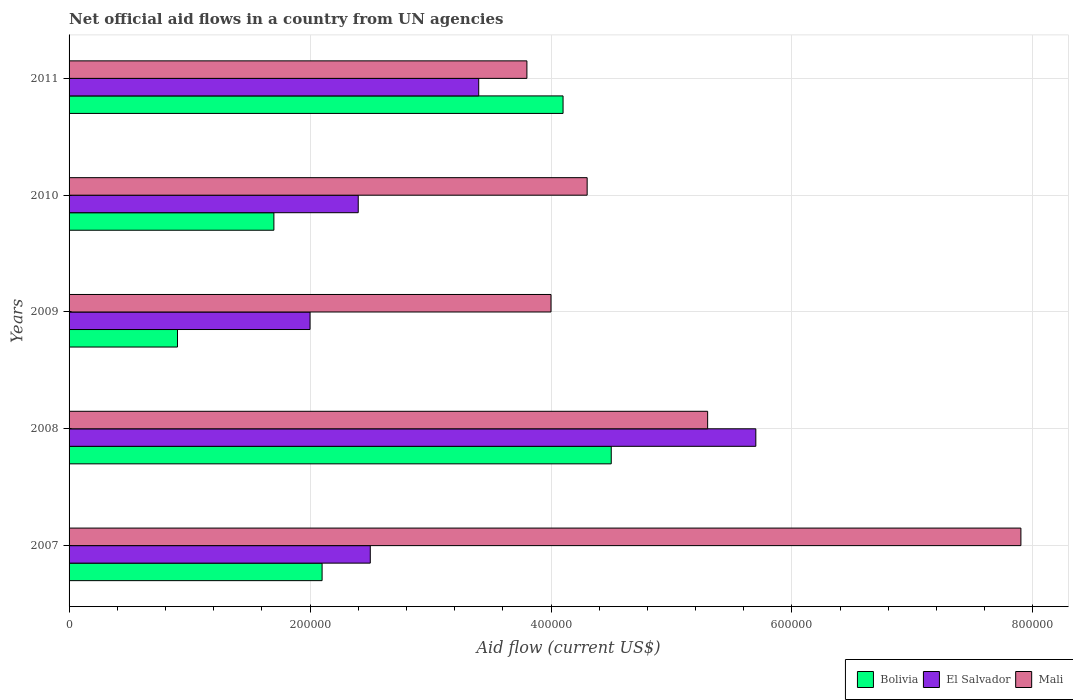Are the number of bars per tick equal to the number of legend labels?
Keep it short and to the point. Yes. How many bars are there on the 3rd tick from the top?
Your answer should be very brief. 3. In how many cases, is the number of bars for a given year not equal to the number of legend labels?
Provide a succinct answer. 0. What is the net official aid flow in Mali in 2008?
Give a very brief answer. 5.30e+05. Across all years, what is the maximum net official aid flow in Bolivia?
Your answer should be compact. 4.50e+05. Across all years, what is the minimum net official aid flow in El Salvador?
Ensure brevity in your answer.  2.00e+05. What is the total net official aid flow in Mali in the graph?
Offer a very short reply. 2.53e+06. What is the difference between the net official aid flow in Bolivia in 2007 and that in 2010?
Your answer should be very brief. 4.00e+04. What is the difference between the net official aid flow in El Salvador in 2011 and the net official aid flow in Mali in 2007?
Your response must be concise. -4.50e+05. What is the average net official aid flow in El Salvador per year?
Give a very brief answer. 3.20e+05. In the year 2009, what is the difference between the net official aid flow in Bolivia and net official aid flow in Mali?
Your response must be concise. -3.10e+05. What is the ratio of the net official aid flow in El Salvador in 2007 to that in 2008?
Your answer should be very brief. 0.44. Is the difference between the net official aid flow in Bolivia in 2007 and 2010 greater than the difference between the net official aid flow in Mali in 2007 and 2010?
Offer a very short reply. No. What is the difference between the highest and the second highest net official aid flow in Mali?
Ensure brevity in your answer.  2.60e+05. What is the difference between the highest and the lowest net official aid flow in El Salvador?
Make the answer very short. 3.70e+05. In how many years, is the net official aid flow in El Salvador greater than the average net official aid flow in El Salvador taken over all years?
Give a very brief answer. 2. What does the 2nd bar from the top in 2007 represents?
Ensure brevity in your answer.  El Salvador. What does the 2nd bar from the bottom in 2009 represents?
Provide a succinct answer. El Salvador. Is it the case that in every year, the sum of the net official aid flow in El Salvador and net official aid flow in Mali is greater than the net official aid flow in Bolivia?
Give a very brief answer. Yes. How many bars are there?
Provide a succinct answer. 15. How many years are there in the graph?
Your response must be concise. 5. Does the graph contain any zero values?
Keep it short and to the point. No. Where does the legend appear in the graph?
Provide a succinct answer. Bottom right. How are the legend labels stacked?
Give a very brief answer. Horizontal. What is the title of the graph?
Provide a succinct answer. Net official aid flows in a country from UN agencies. Does "India" appear as one of the legend labels in the graph?
Your answer should be very brief. No. What is the label or title of the Y-axis?
Offer a terse response. Years. What is the Aid flow (current US$) of Bolivia in 2007?
Provide a short and direct response. 2.10e+05. What is the Aid flow (current US$) in Mali in 2007?
Keep it short and to the point. 7.90e+05. What is the Aid flow (current US$) of El Salvador in 2008?
Give a very brief answer. 5.70e+05. What is the Aid flow (current US$) of Mali in 2008?
Give a very brief answer. 5.30e+05. What is the Aid flow (current US$) of El Salvador in 2009?
Make the answer very short. 2.00e+05. What is the Aid flow (current US$) in Bolivia in 2011?
Your answer should be very brief. 4.10e+05. Across all years, what is the maximum Aid flow (current US$) of Bolivia?
Provide a succinct answer. 4.50e+05. Across all years, what is the maximum Aid flow (current US$) of El Salvador?
Make the answer very short. 5.70e+05. Across all years, what is the maximum Aid flow (current US$) of Mali?
Make the answer very short. 7.90e+05. Across all years, what is the minimum Aid flow (current US$) in Bolivia?
Offer a terse response. 9.00e+04. Across all years, what is the minimum Aid flow (current US$) in El Salvador?
Your answer should be compact. 2.00e+05. What is the total Aid flow (current US$) of Bolivia in the graph?
Offer a terse response. 1.33e+06. What is the total Aid flow (current US$) of El Salvador in the graph?
Your answer should be very brief. 1.60e+06. What is the total Aid flow (current US$) in Mali in the graph?
Keep it short and to the point. 2.53e+06. What is the difference between the Aid flow (current US$) in Bolivia in 2007 and that in 2008?
Ensure brevity in your answer.  -2.40e+05. What is the difference between the Aid flow (current US$) in El Salvador in 2007 and that in 2008?
Give a very brief answer. -3.20e+05. What is the difference between the Aid flow (current US$) in Mali in 2007 and that in 2008?
Provide a succinct answer. 2.60e+05. What is the difference between the Aid flow (current US$) in El Salvador in 2007 and that in 2009?
Offer a terse response. 5.00e+04. What is the difference between the Aid flow (current US$) in Mali in 2007 and that in 2009?
Provide a short and direct response. 3.90e+05. What is the difference between the Aid flow (current US$) of Bolivia in 2007 and that in 2010?
Provide a succinct answer. 4.00e+04. What is the difference between the Aid flow (current US$) of El Salvador in 2007 and that in 2010?
Give a very brief answer. 10000. What is the difference between the Aid flow (current US$) in Bolivia in 2007 and that in 2011?
Make the answer very short. -2.00e+05. What is the difference between the Aid flow (current US$) of El Salvador in 2007 and that in 2011?
Make the answer very short. -9.00e+04. What is the difference between the Aid flow (current US$) in Mali in 2007 and that in 2011?
Offer a terse response. 4.10e+05. What is the difference between the Aid flow (current US$) of Bolivia in 2008 and that in 2009?
Make the answer very short. 3.60e+05. What is the difference between the Aid flow (current US$) in Mali in 2008 and that in 2009?
Provide a succinct answer. 1.30e+05. What is the difference between the Aid flow (current US$) of El Salvador in 2008 and that in 2010?
Provide a short and direct response. 3.30e+05. What is the difference between the Aid flow (current US$) of Mali in 2008 and that in 2010?
Your answer should be very brief. 1.00e+05. What is the difference between the Aid flow (current US$) in El Salvador in 2008 and that in 2011?
Offer a terse response. 2.30e+05. What is the difference between the Aid flow (current US$) in Mali in 2008 and that in 2011?
Make the answer very short. 1.50e+05. What is the difference between the Aid flow (current US$) of Bolivia in 2009 and that in 2010?
Provide a succinct answer. -8.00e+04. What is the difference between the Aid flow (current US$) of El Salvador in 2009 and that in 2010?
Your answer should be compact. -4.00e+04. What is the difference between the Aid flow (current US$) of Bolivia in 2009 and that in 2011?
Provide a succinct answer. -3.20e+05. What is the difference between the Aid flow (current US$) in El Salvador in 2009 and that in 2011?
Offer a terse response. -1.40e+05. What is the difference between the Aid flow (current US$) in Mali in 2009 and that in 2011?
Ensure brevity in your answer.  2.00e+04. What is the difference between the Aid flow (current US$) of Mali in 2010 and that in 2011?
Provide a short and direct response. 5.00e+04. What is the difference between the Aid flow (current US$) in Bolivia in 2007 and the Aid flow (current US$) in El Salvador in 2008?
Offer a terse response. -3.60e+05. What is the difference between the Aid flow (current US$) of Bolivia in 2007 and the Aid flow (current US$) of Mali in 2008?
Offer a very short reply. -3.20e+05. What is the difference between the Aid flow (current US$) of El Salvador in 2007 and the Aid flow (current US$) of Mali in 2008?
Provide a succinct answer. -2.80e+05. What is the difference between the Aid flow (current US$) in Bolivia in 2007 and the Aid flow (current US$) in El Salvador in 2009?
Your response must be concise. 10000. What is the difference between the Aid flow (current US$) in El Salvador in 2008 and the Aid flow (current US$) in Mali in 2010?
Give a very brief answer. 1.40e+05. What is the difference between the Aid flow (current US$) in Bolivia in 2008 and the Aid flow (current US$) in Mali in 2011?
Your response must be concise. 7.00e+04. What is the difference between the Aid flow (current US$) of El Salvador in 2008 and the Aid flow (current US$) of Mali in 2011?
Your answer should be very brief. 1.90e+05. What is the difference between the Aid flow (current US$) of Bolivia in 2009 and the Aid flow (current US$) of Mali in 2010?
Offer a very short reply. -3.40e+05. What is the difference between the Aid flow (current US$) in El Salvador in 2009 and the Aid flow (current US$) in Mali in 2010?
Provide a succinct answer. -2.30e+05. What is the difference between the Aid flow (current US$) in Bolivia in 2009 and the Aid flow (current US$) in El Salvador in 2011?
Ensure brevity in your answer.  -2.50e+05. What is the difference between the Aid flow (current US$) of Bolivia in 2009 and the Aid flow (current US$) of Mali in 2011?
Provide a short and direct response. -2.90e+05. What is the difference between the Aid flow (current US$) in El Salvador in 2009 and the Aid flow (current US$) in Mali in 2011?
Offer a very short reply. -1.80e+05. What is the difference between the Aid flow (current US$) in Bolivia in 2010 and the Aid flow (current US$) in Mali in 2011?
Offer a very short reply. -2.10e+05. What is the difference between the Aid flow (current US$) in El Salvador in 2010 and the Aid flow (current US$) in Mali in 2011?
Your response must be concise. -1.40e+05. What is the average Aid flow (current US$) in Bolivia per year?
Ensure brevity in your answer.  2.66e+05. What is the average Aid flow (current US$) of El Salvador per year?
Provide a short and direct response. 3.20e+05. What is the average Aid flow (current US$) of Mali per year?
Your response must be concise. 5.06e+05. In the year 2007, what is the difference between the Aid flow (current US$) in Bolivia and Aid flow (current US$) in El Salvador?
Your answer should be compact. -4.00e+04. In the year 2007, what is the difference between the Aid flow (current US$) of Bolivia and Aid flow (current US$) of Mali?
Your answer should be very brief. -5.80e+05. In the year 2007, what is the difference between the Aid flow (current US$) of El Salvador and Aid flow (current US$) of Mali?
Offer a very short reply. -5.40e+05. In the year 2008, what is the difference between the Aid flow (current US$) in Bolivia and Aid flow (current US$) in El Salvador?
Offer a very short reply. -1.20e+05. In the year 2008, what is the difference between the Aid flow (current US$) in Bolivia and Aid flow (current US$) in Mali?
Your response must be concise. -8.00e+04. In the year 2008, what is the difference between the Aid flow (current US$) in El Salvador and Aid flow (current US$) in Mali?
Your response must be concise. 4.00e+04. In the year 2009, what is the difference between the Aid flow (current US$) of Bolivia and Aid flow (current US$) of Mali?
Offer a terse response. -3.10e+05. In the year 2010, what is the difference between the Aid flow (current US$) of Bolivia and Aid flow (current US$) of Mali?
Offer a very short reply. -2.60e+05. In the year 2011, what is the difference between the Aid flow (current US$) of Bolivia and Aid flow (current US$) of El Salvador?
Your answer should be very brief. 7.00e+04. In the year 2011, what is the difference between the Aid flow (current US$) of Bolivia and Aid flow (current US$) of Mali?
Provide a short and direct response. 3.00e+04. What is the ratio of the Aid flow (current US$) of Bolivia in 2007 to that in 2008?
Make the answer very short. 0.47. What is the ratio of the Aid flow (current US$) in El Salvador in 2007 to that in 2008?
Provide a short and direct response. 0.44. What is the ratio of the Aid flow (current US$) of Mali in 2007 to that in 2008?
Keep it short and to the point. 1.49. What is the ratio of the Aid flow (current US$) in Bolivia in 2007 to that in 2009?
Make the answer very short. 2.33. What is the ratio of the Aid flow (current US$) in El Salvador in 2007 to that in 2009?
Your answer should be compact. 1.25. What is the ratio of the Aid flow (current US$) in Mali in 2007 to that in 2009?
Your answer should be compact. 1.98. What is the ratio of the Aid flow (current US$) in Bolivia in 2007 to that in 2010?
Keep it short and to the point. 1.24. What is the ratio of the Aid flow (current US$) of El Salvador in 2007 to that in 2010?
Your answer should be very brief. 1.04. What is the ratio of the Aid flow (current US$) in Mali in 2007 to that in 2010?
Provide a succinct answer. 1.84. What is the ratio of the Aid flow (current US$) in Bolivia in 2007 to that in 2011?
Offer a very short reply. 0.51. What is the ratio of the Aid flow (current US$) of El Salvador in 2007 to that in 2011?
Ensure brevity in your answer.  0.74. What is the ratio of the Aid flow (current US$) of Mali in 2007 to that in 2011?
Offer a terse response. 2.08. What is the ratio of the Aid flow (current US$) of Bolivia in 2008 to that in 2009?
Provide a succinct answer. 5. What is the ratio of the Aid flow (current US$) in El Salvador in 2008 to that in 2009?
Your answer should be very brief. 2.85. What is the ratio of the Aid flow (current US$) in Mali in 2008 to that in 2009?
Your response must be concise. 1.32. What is the ratio of the Aid flow (current US$) in Bolivia in 2008 to that in 2010?
Your answer should be very brief. 2.65. What is the ratio of the Aid flow (current US$) in El Salvador in 2008 to that in 2010?
Your response must be concise. 2.38. What is the ratio of the Aid flow (current US$) of Mali in 2008 to that in 2010?
Ensure brevity in your answer.  1.23. What is the ratio of the Aid flow (current US$) in Bolivia in 2008 to that in 2011?
Provide a succinct answer. 1.1. What is the ratio of the Aid flow (current US$) in El Salvador in 2008 to that in 2011?
Provide a short and direct response. 1.68. What is the ratio of the Aid flow (current US$) in Mali in 2008 to that in 2011?
Offer a terse response. 1.39. What is the ratio of the Aid flow (current US$) of Bolivia in 2009 to that in 2010?
Your answer should be compact. 0.53. What is the ratio of the Aid flow (current US$) in El Salvador in 2009 to that in 2010?
Ensure brevity in your answer.  0.83. What is the ratio of the Aid flow (current US$) in Mali in 2009 to that in 2010?
Provide a short and direct response. 0.93. What is the ratio of the Aid flow (current US$) in Bolivia in 2009 to that in 2011?
Keep it short and to the point. 0.22. What is the ratio of the Aid flow (current US$) of El Salvador in 2009 to that in 2011?
Offer a terse response. 0.59. What is the ratio of the Aid flow (current US$) of Mali in 2009 to that in 2011?
Give a very brief answer. 1.05. What is the ratio of the Aid flow (current US$) of Bolivia in 2010 to that in 2011?
Make the answer very short. 0.41. What is the ratio of the Aid flow (current US$) in El Salvador in 2010 to that in 2011?
Provide a succinct answer. 0.71. What is the ratio of the Aid flow (current US$) in Mali in 2010 to that in 2011?
Offer a very short reply. 1.13. What is the difference between the highest and the lowest Aid flow (current US$) of El Salvador?
Your response must be concise. 3.70e+05. What is the difference between the highest and the lowest Aid flow (current US$) of Mali?
Your answer should be compact. 4.10e+05. 